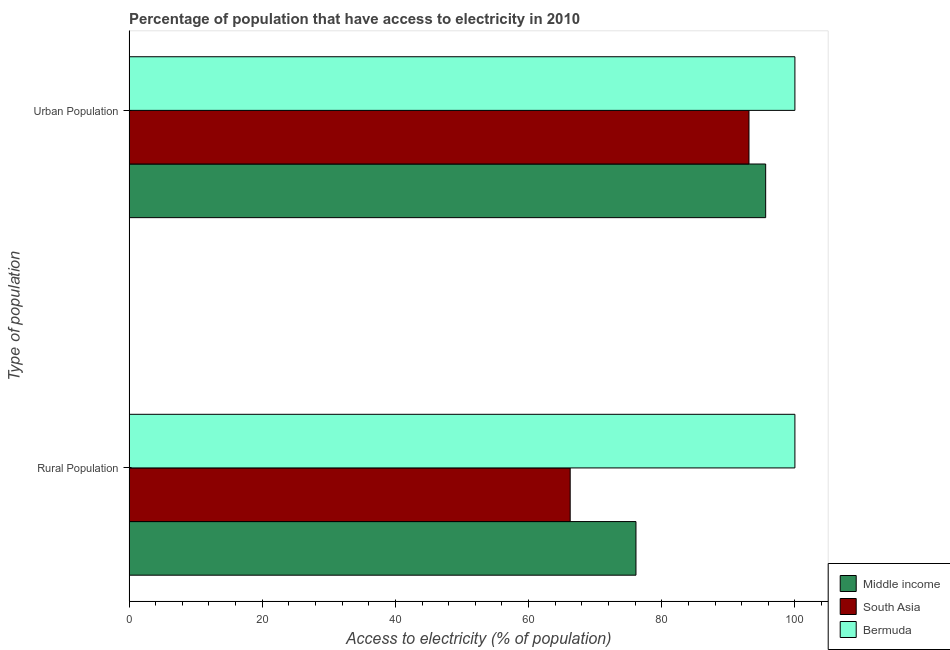Are the number of bars per tick equal to the number of legend labels?
Provide a short and direct response. Yes. Are the number of bars on each tick of the Y-axis equal?
Offer a very short reply. Yes. How many bars are there on the 1st tick from the bottom?
Make the answer very short. 3. What is the label of the 1st group of bars from the top?
Ensure brevity in your answer.  Urban Population. What is the percentage of urban population having access to electricity in Middle income?
Offer a very short reply. 95.61. Across all countries, what is the maximum percentage of rural population having access to electricity?
Your response must be concise. 100. Across all countries, what is the minimum percentage of rural population having access to electricity?
Offer a terse response. 66.25. In which country was the percentage of rural population having access to electricity maximum?
Your response must be concise. Bermuda. In which country was the percentage of rural population having access to electricity minimum?
Provide a succinct answer. South Asia. What is the total percentage of rural population having access to electricity in the graph?
Your response must be concise. 242.38. What is the difference between the percentage of urban population having access to electricity in Middle income and that in South Asia?
Ensure brevity in your answer.  2.51. What is the difference between the percentage of urban population having access to electricity in Bermuda and the percentage of rural population having access to electricity in Middle income?
Make the answer very short. 23.87. What is the average percentage of rural population having access to electricity per country?
Provide a succinct answer. 80.79. What is the difference between the percentage of urban population having access to electricity and percentage of rural population having access to electricity in Middle income?
Your response must be concise. 19.48. What is the ratio of the percentage of rural population having access to electricity in South Asia to that in Bermuda?
Keep it short and to the point. 0.66. Is the percentage of urban population having access to electricity in South Asia less than that in Bermuda?
Make the answer very short. Yes. What does the 3rd bar from the bottom in Urban Population represents?
Provide a short and direct response. Bermuda. Are all the bars in the graph horizontal?
Provide a short and direct response. Yes. How many countries are there in the graph?
Provide a succinct answer. 3. What is the difference between two consecutive major ticks on the X-axis?
Provide a succinct answer. 20. Does the graph contain any zero values?
Ensure brevity in your answer.  No. Where does the legend appear in the graph?
Your response must be concise. Bottom right. What is the title of the graph?
Your response must be concise. Percentage of population that have access to electricity in 2010. What is the label or title of the X-axis?
Your answer should be very brief. Access to electricity (% of population). What is the label or title of the Y-axis?
Offer a terse response. Type of population. What is the Access to electricity (% of population) of Middle income in Rural Population?
Ensure brevity in your answer.  76.13. What is the Access to electricity (% of population) of South Asia in Rural Population?
Your answer should be very brief. 66.25. What is the Access to electricity (% of population) of Middle income in Urban Population?
Give a very brief answer. 95.61. What is the Access to electricity (% of population) in South Asia in Urban Population?
Make the answer very short. 93.1. What is the Access to electricity (% of population) in Bermuda in Urban Population?
Your answer should be very brief. 100. Across all Type of population, what is the maximum Access to electricity (% of population) of Middle income?
Provide a short and direct response. 95.61. Across all Type of population, what is the maximum Access to electricity (% of population) in South Asia?
Ensure brevity in your answer.  93.1. Across all Type of population, what is the minimum Access to electricity (% of population) in Middle income?
Your response must be concise. 76.13. Across all Type of population, what is the minimum Access to electricity (% of population) of South Asia?
Offer a terse response. 66.25. Across all Type of population, what is the minimum Access to electricity (% of population) in Bermuda?
Your response must be concise. 100. What is the total Access to electricity (% of population) in Middle income in the graph?
Offer a very short reply. 171.74. What is the total Access to electricity (% of population) of South Asia in the graph?
Offer a very short reply. 159.36. What is the difference between the Access to electricity (% of population) of Middle income in Rural Population and that in Urban Population?
Offer a terse response. -19.48. What is the difference between the Access to electricity (% of population) in South Asia in Rural Population and that in Urban Population?
Give a very brief answer. -26.85. What is the difference between the Access to electricity (% of population) in Bermuda in Rural Population and that in Urban Population?
Your response must be concise. 0. What is the difference between the Access to electricity (% of population) of Middle income in Rural Population and the Access to electricity (% of population) of South Asia in Urban Population?
Make the answer very short. -16.97. What is the difference between the Access to electricity (% of population) of Middle income in Rural Population and the Access to electricity (% of population) of Bermuda in Urban Population?
Keep it short and to the point. -23.87. What is the difference between the Access to electricity (% of population) of South Asia in Rural Population and the Access to electricity (% of population) of Bermuda in Urban Population?
Give a very brief answer. -33.75. What is the average Access to electricity (% of population) of Middle income per Type of population?
Offer a very short reply. 85.87. What is the average Access to electricity (% of population) in South Asia per Type of population?
Provide a short and direct response. 79.68. What is the difference between the Access to electricity (% of population) in Middle income and Access to electricity (% of population) in South Asia in Rural Population?
Your answer should be very brief. 9.88. What is the difference between the Access to electricity (% of population) of Middle income and Access to electricity (% of population) of Bermuda in Rural Population?
Keep it short and to the point. -23.87. What is the difference between the Access to electricity (% of population) of South Asia and Access to electricity (% of population) of Bermuda in Rural Population?
Offer a terse response. -33.75. What is the difference between the Access to electricity (% of population) of Middle income and Access to electricity (% of population) of South Asia in Urban Population?
Offer a very short reply. 2.51. What is the difference between the Access to electricity (% of population) in Middle income and Access to electricity (% of population) in Bermuda in Urban Population?
Provide a short and direct response. -4.39. What is the difference between the Access to electricity (% of population) of South Asia and Access to electricity (% of population) of Bermuda in Urban Population?
Your answer should be very brief. -6.9. What is the ratio of the Access to electricity (% of population) in Middle income in Rural Population to that in Urban Population?
Your answer should be compact. 0.8. What is the ratio of the Access to electricity (% of population) in South Asia in Rural Population to that in Urban Population?
Make the answer very short. 0.71. What is the difference between the highest and the second highest Access to electricity (% of population) of Middle income?
Your response must be concise. 19.48. What is the difference between the highest and the second highest Access to electricity (% of population) of South Asia?
Give a very brief answer. 26.85. What is the difference between the highest and the second highest Access to electricity (% of population) in Bermuda?
Give a very brief answer. 0. What is the difference between the highest and the lowest Access to electricity (% of population) of Middle income?
Keep it short and to the point. 19.48. What is the difference between the highest and the lowest Access to electricity (% of population) in South Asia?
Provide a succinct answer. 26.85. 